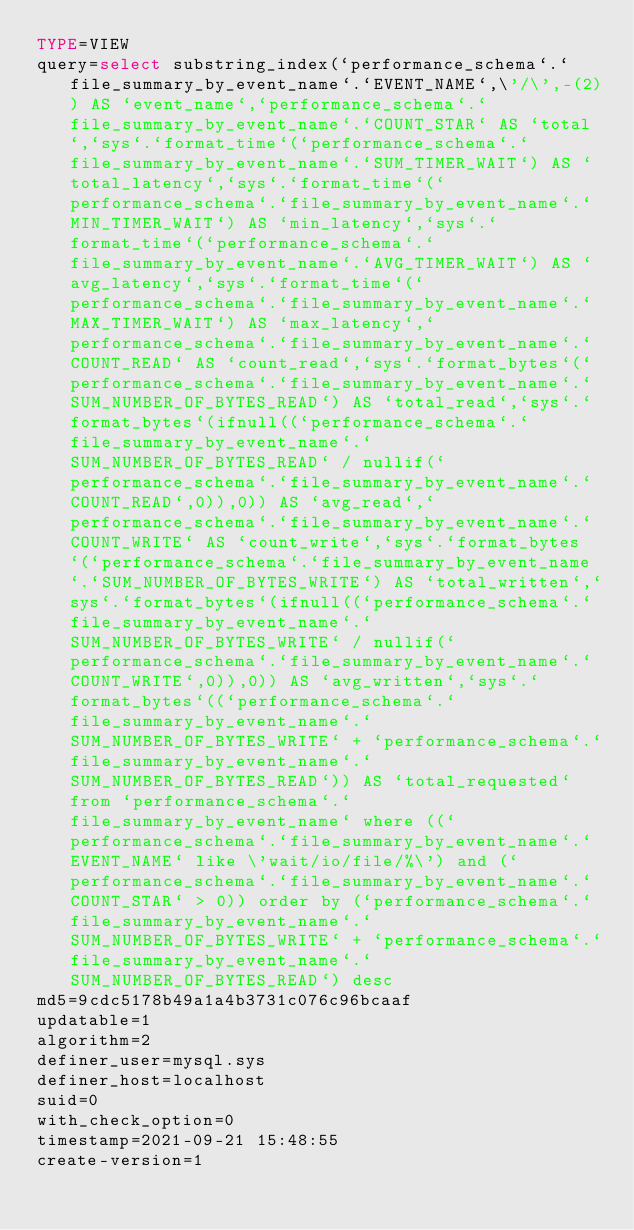<code> <loc_0><loc_0><loc_500><loc_500><_VisualBasic_>TYPE=VIEW
query=select substring_index(`performance_schema`.`file_summary_by_event_name`.`EVENT_NAME`,\'/\',-(2)) AS `event_name`,`performance_schema`.`file_summary_by_event_name`.`COUNT_STAR` AS `total`,`sys`.`format_time`(`performance_schema`.`file_summary_by_event_name`.`SUM_TIMER_WAIT`) AS `total_latency`,`sys`.`format_time`(`performance_schema`.`file_summary_by_event_name`.`MIN_TIMER_WAIT`) AS `min_latency`,`sys`.`format_time`(`performance_schema`.`file_summary_by_event_name`.`AVG_TIMER_WAIT`) AS `avg_latency`,`sys`.`format_time`(`performance_schema`.`file_summary_by_event_name`.`MAX_TIMER_WAIT`) AS `max_latency`,`performance_schema`.`file_summary_by_event_name`.`COUNT_READ` AS `count_read`,`sys`.`format_bytes`(`performance_schema`.`file_summary_by_event_name`.`SUM_NUMBER_OF_BYTES_READ`) AS `total_read`,`sys`.`format_bytes`(ifnull((`performance_schema`.`file_summary_by_event_name`.`SUM_NUMBER_OF_BYTES_READ` / nullif(`performance_schema`.`file_summary_by_event_name`.`COUNT_READ`,0)),0)) AS `avg_read`,`performance_schema`.`file_summary_by_event_name`.`COUNT_WRITE` AS `count_write`,`sys`.`format_bytes`(`performance_schema`.`file_summary_by_event_name`.`SUM_NUMBER_OF_BYTES_WRITE`) AS `total_written`,`sys`.`format_bytes`(ifnull((`performance_schema`.`file_summary_by_event_name`.`SUM_NUMBER_OF_BYTES_WRITE` / nullif(`performance_schema`.`file_summary_by_event_name`.`COUNT_WRITE`,0)),0)) AS `avg_written`,`sys`.`format_bytes`((`performance_schema`.`file_summary_by_event_name`.`SUM_NUMBER_OF_BYTES_WRITE` + `performance_schema`.`file_summary_by_event_name`.`SUM_NUMBER_OF_BYTES_READ`)) AS `total_requested` from `performance_schema`.`file_summary_by_event_name` where ((`performance_schema`.`file_summary_by_event_name`.`EVENT_NAME` like \'wait/io/file/%\') and (`performance_schema`.`file_summary_by_event_name`.`COUNT_STAR` > 0)) order by (`performance_schema`.`file_summary_by_event_name`.`SUM_NUMBER_OF_BYTES_WRITE` + `performance_schema`.`file_summary_by_event_name`.`SUM_NUMBER_OF_BYTES_READ`) desc
md5=9cdc5178b49a1a4b3731c076c96bcaaf
updatable=1
algorithm=2
definer_user=mysql.sys
definer_host=localhost
suid=0
with_check_option=0
timestamp=2021-09-21 15:48:55
create-version=1</code> 